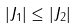<formula> <loc_0><loc_0><loc_500><loc_500>| J _ { 1 } | \leq | J _ { 2 } |</formula> 